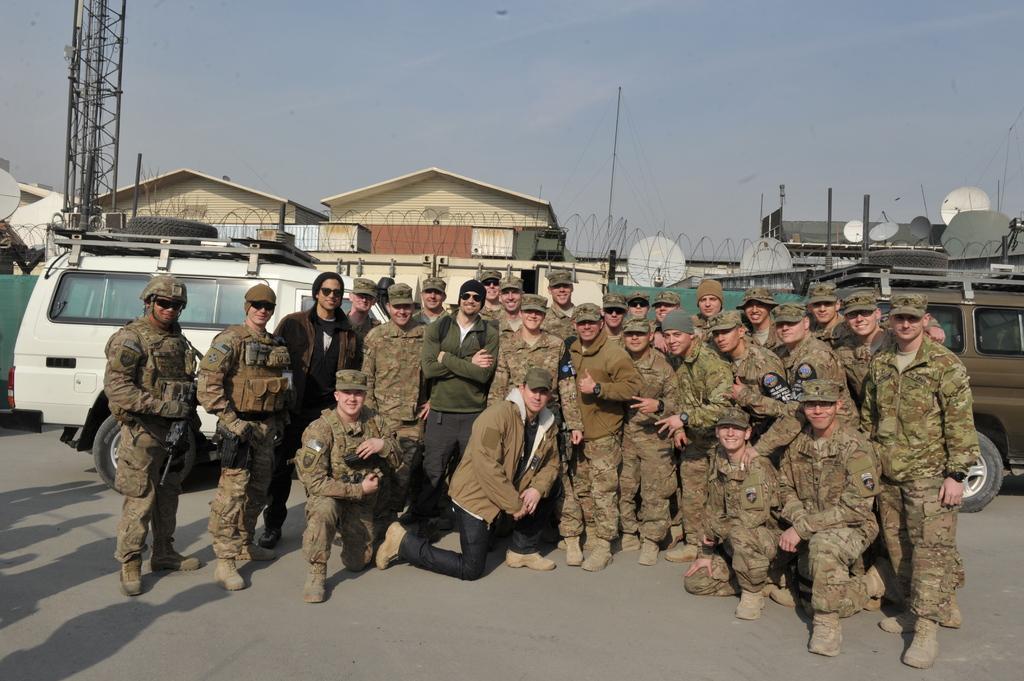Could you give a brief overview of what you see in this image? In this image we can see some army soldiers are posing for a photo and we can see vehicles behind them. In the background, we can see a few building and at the top, we can see the sky. 